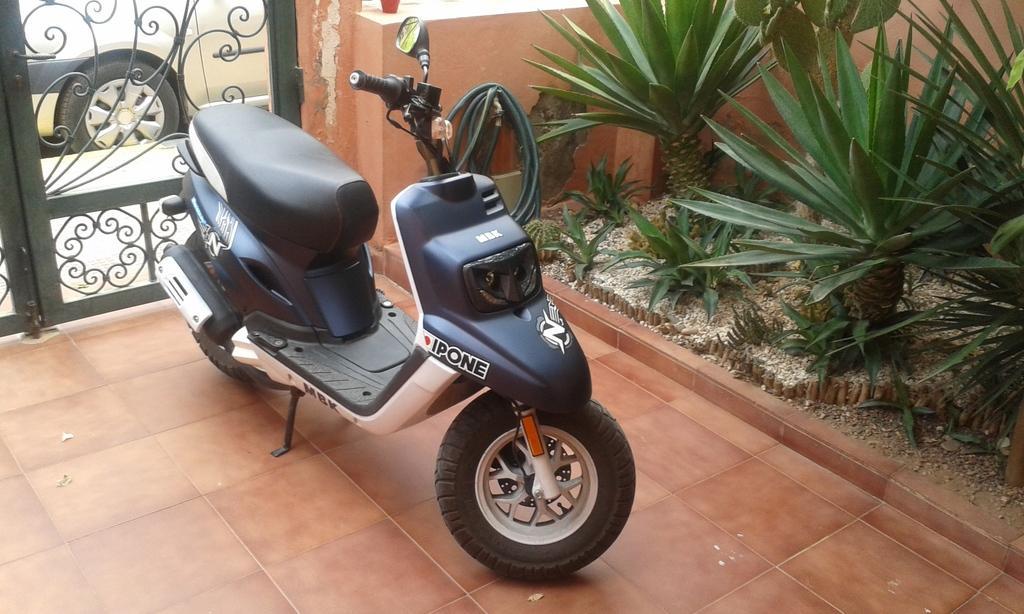How would you summarize this image in a sentence or two? In this picture I can observe a bike parked on the floor. On the right side I can observe some plants. On the left side there is a gate. Behind the gate I can observe a car. 